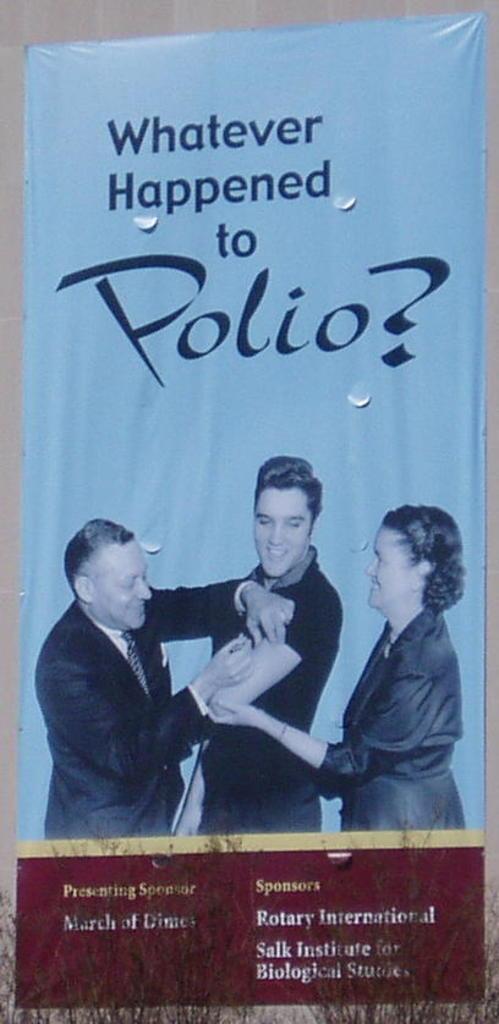What organization is the main sponsor?
Your answer should be compact. Rotary international. 